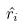<formula> <loc_0><loc_0><loc_500><loc_500>\hat { r _ { i } }</formula> 